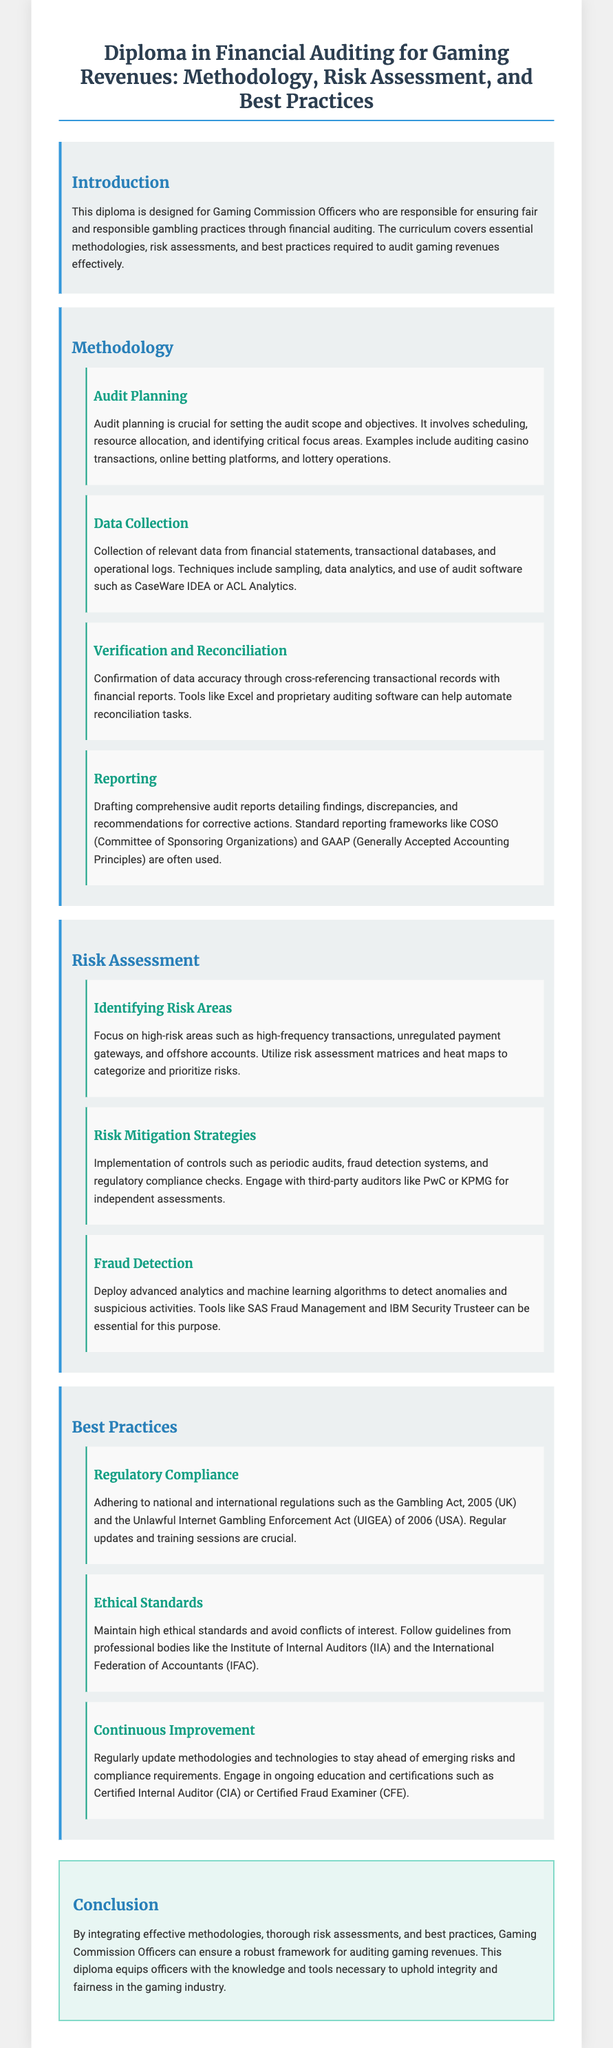What is the title of the diploma? The title is found prominently at the top of the document, summarizing the focus of the curriculum.
Answer: Diploma in Financial Auditing for Gaming Revenues: Methodology, Risk Assessment, and Best Practices Who is the target audience for this diploma? The introduction specifies who the diploma is designed for, emphasizing the role of the audience in the gaming industry.
Answer: Gaming Commission Officers What does the methodology section discuss? The methodology section encompasses various subtopics related to auditing practices, as outlined in the document's main structure.
Answer: Audit Planning, Data Collection, Verification and Reconciliation, Reporting What is the purpose of audit planning? The subsection explains the significance of audit planning in the auditing process and what it entails.
Answer: Setting the audit scope and objectives What tools are mentioned for fraud detection? The fraud detection subsection lists specific tools that assist in identifying fraudulent activities.
Answer: SAS Fraud Management and IBM Security Trusteer What regulatory compliance is highlighted? The document outlines certain regulations that must be adhered to within the gaming industry.
Answer: Gambling Act, 2005 (UK) and UIGEA of 2006 (USA) What is the focus of risk assessment? The risk assessment section identifies specific goals related to assessing risks in the gaming industry.
Answer: Identifying Risk Areas What does continuous improvement emphasize? The best practices subsection highlights the significance of regularly updating practices in response to change.
Answer: Regularly update methodologies and technologies What is the concluding statement of the diploma? The conclusion summarizes the overall aim and importance of the diploma.
Answer: A robust framework for auditing gaming revenues 